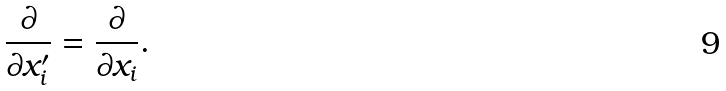Convert formula to latex. <formula><loc_0><loc_0><loc_500><loc_500>\frac { \partial } { \partial x ^ { \prime } _ { i } } = \frac { \partial } { \partial x _ { i } } .</formula> 